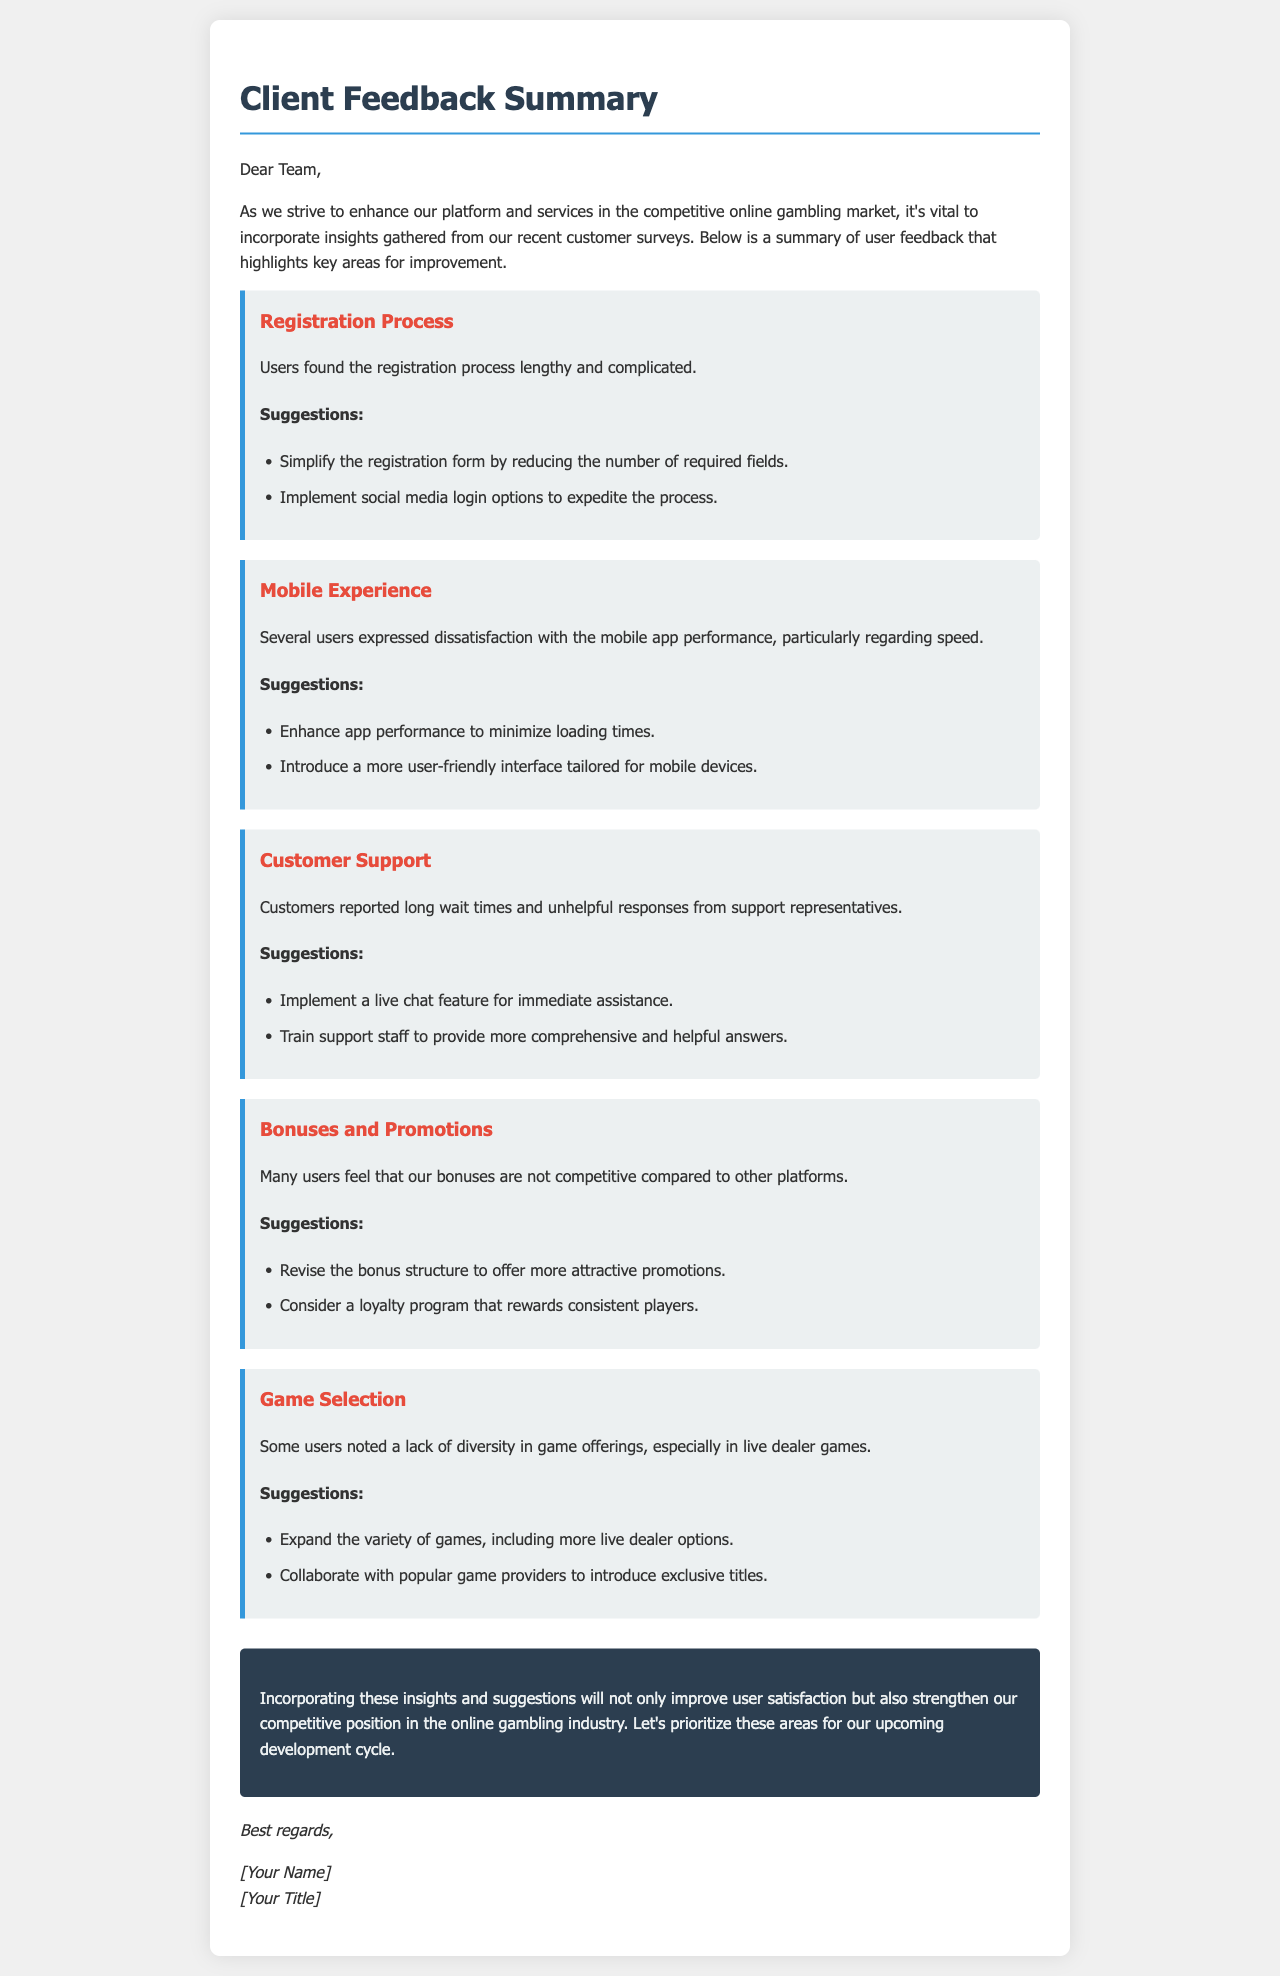What are the key areas for improvement? The letter highlights key areas for improvement which include Registration Process, Mobile Experience, Customer Support, Bonuses and Promotions, and Game Selection.
Answer: Registration Process, Mobile Experience, Customer Support, Bonuses and Promotions, Game Selection What suggestion is made for the registration process? One suggestion made to improve the registration process is to simplify the registration form by reducing the number of required fields.
Answer: Simplify the registration form What issue was reported regarding customer support? Customers reported long wait times and unhelpful responses from support representatives.
Answer: Long wait times and unhelpful responses What bonus-related suggestion was mentioned? The suggestion mentioned for bonuses is to revise the bonus structure to offer more attractive promotions.
Answer: Revise the bonus structure How many feedback items are included in the summary? The summary contains five feedback items detailing user suggestions for improvement.
Answer: Five What conclusion is drawn in the document? The conclusion emphasizes that incorporating user insights will improve satisfaction and strengthen competitive position.
Answer: Improve user satisfaction and competitive position What feature is suggested for immediate customer assistance? The document suggests implementing a live chat feature for immediate assistance.
Answer: Live chat feature On which aspect of the platform do users want more diversity? Users noted a lack of diversity in game offerings, particularly in live dealer games.
Answer: Game offerings What is the overall purpose of this document? The overall purpose of the document is to compile user insights and suggestions from customer surveys to enhance the platform and services.
Answer: Enhance platform and services 